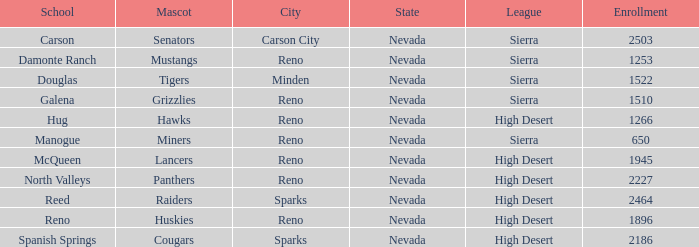What city and state is the Lancers mascot located? Reno, Nevada. 